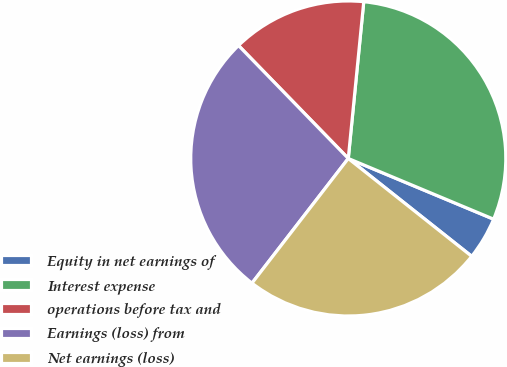Convert chart. <chart><loc_0><loc_0><loc_500><loc_500><pie_chart><fcel>Equity in net earnings of<fcel>Interest expense<fcel>operations before tax and<fcel>Earnings (loss) from<fcel>Net earnings (loss)<nl><fcel>4.37%<fcel>29.73%<fcel>13.84%<fcel>27.26%<fcel>24.8%<nl></chart> 